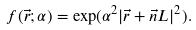<formula> <loc_0><loc_0><loc_500><loc_500>f ( \vec { r } ; \alpha ) = \exp ( \alpha ^ { 2 } | \vec { r } + \vec { n } L | ^ { 2 } ) .</formula> 